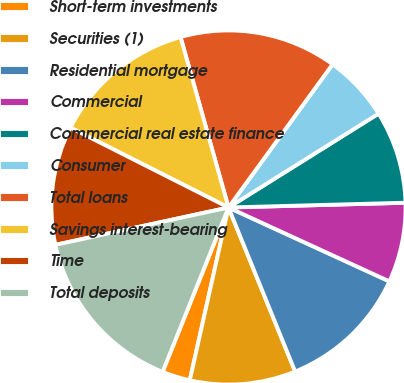Convert chart. <chart><loc_0><loc_0><loc_500><loc_500><pie_chart><fcel>Short-term investments<fcel>Securities (1)<fcel>Residential mortgage<fcel>Commercial<fcel>Commercial real estate finance<fcel>Consumer<fcel>Total loans<fcel>Savings interest-bearing<fcel>Time<fcel>Total deposits<nl><fcel>2.56%<fcel>9.65%<fcel>12.01%<fcel>7.28%<fcel>8.47%<fcel>6.1%<fcel>14.37%<fcel>13.19%<fcel>10.83%<fcel>15.55%<nl></chart> 